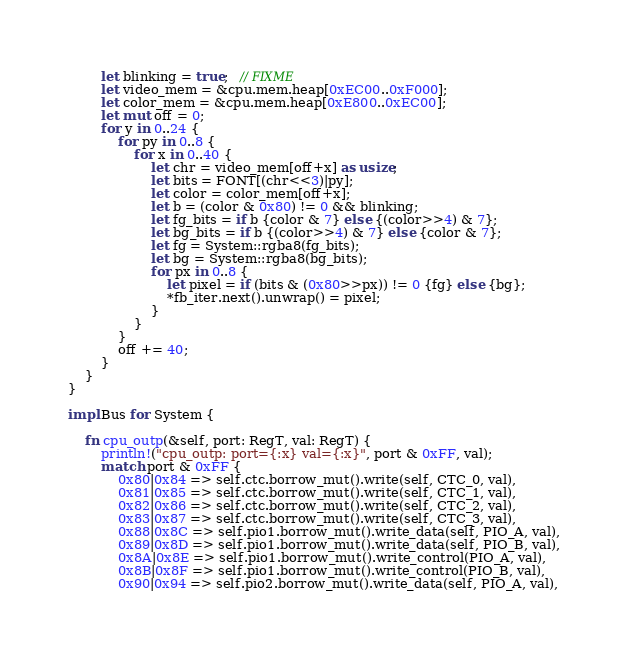<code> <loc_0><loc_0><loc_500><loc_500><_Rust_>        let blinking = true;   // FIXME
        let video_mem = &cpu.mem.heap[0xEC00..0xF000];
        let color_mem = &cpu.mem.heap[0xE800..0xEC00];
        let mut off = 0;
        for y in 0..24 {
            for py in 0..8 {
                for x in 0..40 {
                    let chr = video_mem[off+x] as usize;
                    let bits = FONT[(chr<<3)|py];
                    let color = color_mem[off+x];
                    let b = (color & 0x80) != 0 && blinking;
                    let fg_bits = if b {color & 7} else {(color>>4) & 7};
                    let bg_bits = if b {(color>>4) & 7} else {color & 7};
                    let fg = System::rgba8(fg_bits);
                    let bg = System::rgba8(bg_bits);
                    for px in 0..8 {
                        let pixel = if (bits & (0x80>>px)) != 0 {fg} else {bg};
                        *fb_iter.next().unwrap() = pixel;
                    }
                }
            }
            off += 40;
        }
    }
}

impl Bus for System {

    fn cpu_outp(&self, port: RegT, val: RegT) {
        println!("cpu_outp: port={:x} val={:x}", port & 0xFF, val);
        match port & 0xFF {
            0x80|0x84 => self.ctc.borrow_mut().write(self, CTC_0, val),
            0x81|0x85 => self.ctc.borrow_mut().write(self, CTC_1, val),
            0x82|0x86 => self.ctc.borrow_mut().write(self, CTC_2, val),
            0x83|0x87 => self.ctc.borrow_mut().write(self, CTC_3, val),
            0x88|0x8C => self.pio1.borrow_mut().write_data(self, PIO_A, val),
            0x89|0x8D => self.pio1.borrow_mut().write_data(self, PIO_B, val),
            0x8A|0x8E => self.pio1.borrow_mut().write_control(PIO_A, val),
            0x8B|0x8F => self.pio1.borrow_mut().write_control(PIO_B, val),
            0x90|0x94 => self.pio2.borrow_mut().write_data(self, PIO_A, val),</code> 